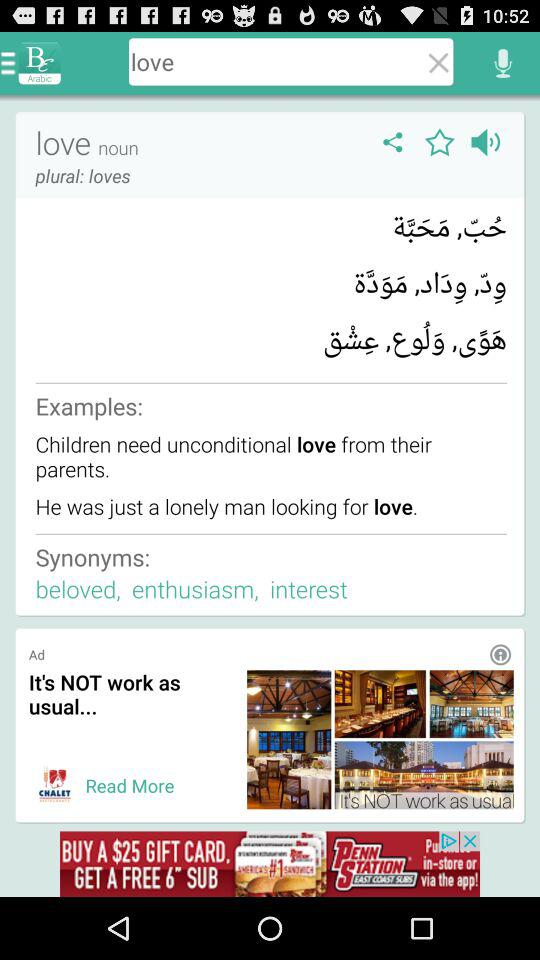What is the given plural noun? The given plural noun is "loves". 